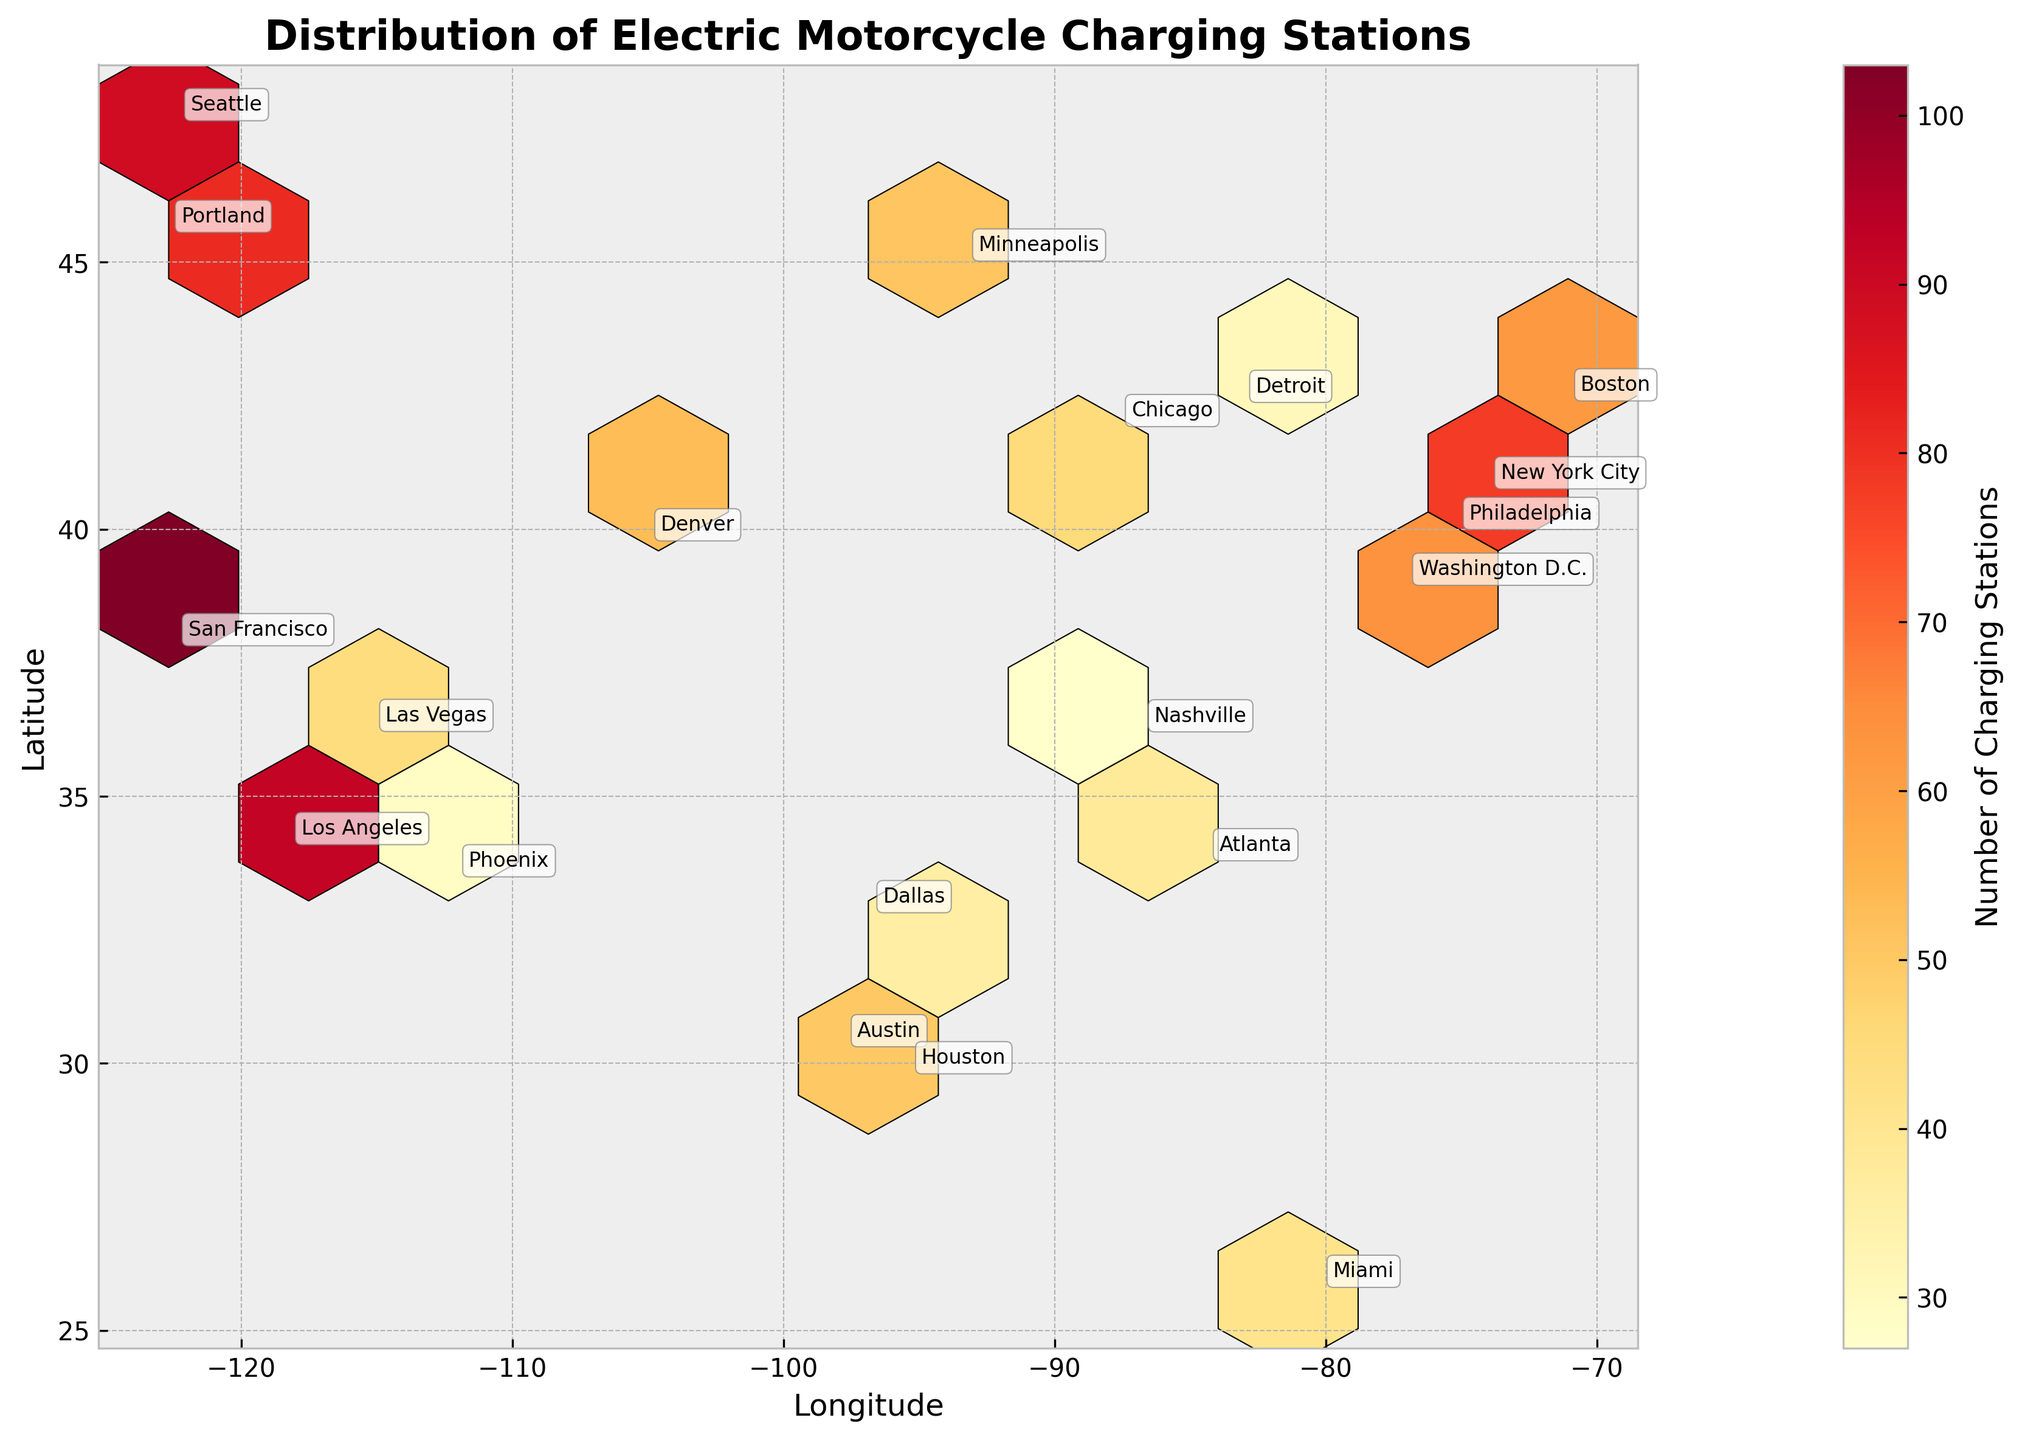What is the title of the plot? The title is typically found at the top of the plot and it summarizes the main purpose or content of the plot. In this hexbin plot, it should contain words related to electric motorcycle charging stations.
Answer: Distribution of Electric Motorcycle Charging Stations What do the colors in the hexbin plot represent? In hexbin plots, colors usually represent the density or value of the bins. Here, the color might indicate the number of charging stations in specific locations.
Answer: Number of Charging Stations How many charging stations are there in San Francisco? Each city is annotated, so find "San Francisco" on the map and check the color of the corresponding hexbin. Then use the color bar to determine the approximate number of charging stations.
Answer: 103 Which city has the highest number of charging stations and how many? To find this, look at the annotations and the colors corresponding to each city. The color bar will help identify the number of stations. The city with the highest count will have the darkest or most saturated color.
Answer: San Francisco, 103 Are there more charging stations in New York City or Los Angeles? Compare the annotations for New York City and Los Angeles. Use the color intensity and the color bar to determine which has more charging stations.
Answer: Los Angeles Which geographic area has the highest concentration of charging stations? This can be identified by finding the area with the highest density of darker hexagons, indicating more charging stations. Use both the map and color bar.
Answer: West Coast (San Francisco, LA) What range of latitudes do the cities span in the plot? Look at the y-axis which represents latitude, and note the highest and lowest latitude mentioned in the plot.
Answer: From ~25.8 to ~47.6 What city located around latitude 45 and longitude -122 has a significant number of charging stations? Using the annotations, find the city around these coordinates and note the number of charging stations.
Answer: Portland, 81 How does the number of charging stations in Boston compare to those in Miami? Locate both Boston and Miami on the hexbin plot, compare their colors, and refer to the color bar for their respective numbers of charging stations.
Answer: Boston has more Based on the plot, which region in the US seems to prioritize electric motorcycle charging infrastructure the most? Examine the density of hexagons and the number of high-value hexagons across different regions. The region with the highest density and number of dark hexagons likely prioritizes this infrastructure.
Answer: West Coast 